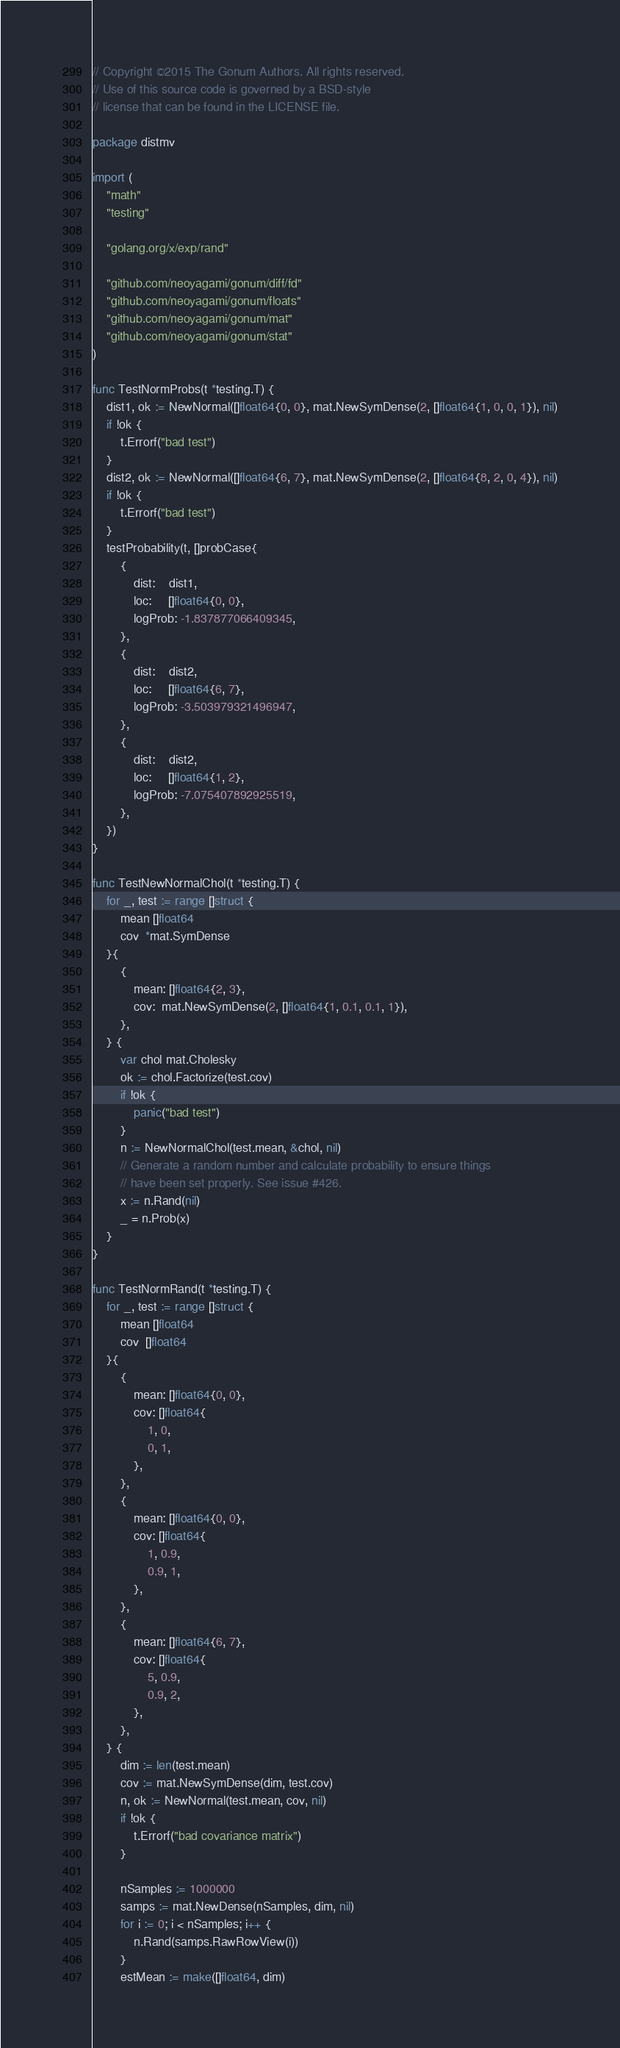<code> <loc_0><loc_0><loc_500><loc_500><_Go_>// Copyright ©2015 The Gonum Authors. All rights reserved.
// Use of this source code is governed by a BSD-style
// license that can be found in the LICENSE file.

package distmv

import (
	"math"
	"testing"

	"golang.org/x/exp/rand"

	"github.com/neoyagami/gonum/diff/fd"
	"github.com/neoyagami/gonum/floats"
	"github.com/neoyagami/gonum/mat"
	"github.com/neoyagami/gonum/stat"
)

func TestNormProbs(t *testing.T) {
	dist1, ok := NewNormal([]float64{0, 0}, mat.NewSymDense(2, []float64{1, 0, 0, 1}), nil)
	if !ok {
		t.Errorf("bad test")
	}
	dist2, ok := NewNormal([]float64{6, 7}, mat.NewSymDense(2, []float64{8, 2, 0, 4}), nil)
	if !ok {
		t.Errorf("bad test")
	}
	testProbability(t, []probCase{
		{
			dist:    dist1,
			loc:     []float64{0, 0},
			logProb: -1.837877066409345,
		},
		{
			dist:    dist2,
			loc:     []float64{6, 7},
			logProb: -3.503979321496947,
		},
		{
			dist:    dist2,
			loc:     []float64{1, 2},
			logProb: -7.075407892925519,
		},
	})
}

func TestNewNormalChol(t *testing.T) {
	for _, test := range []struct {
		mean []float64
		cov  *mat.SymDense
	}{
		{
			mean: []float64{2, 3},
			cov:  mat.NewSymDense(2, []float64{1, 0.1, 0.1, 1}),
		},
	} {
		var chol mat.Cholesky
		ok := chol.Factorize(test.cov)
		if !ok {
			panic("bad test")
		}
		n := NewNormalChol(test.mean, &chol, nil)
		// Generate a random number and calculate probability to ensure things
		// have been set properly. See issue #426.
		x := n.Rand(nil)
		_ = n.Prob(x)
	}
}

func TestNormRand(t *testing.T) {
	for _, test := range []struct {
		mean []float64
		cov  []float64
	}{
		{
			mean: []float64{0, 0},
			cov: []float64{
				1, 0,
				0, 1,
			},
		},
		{
			mean: []float64{0, 0},
			cov: []float64{
				1, 0.9,
				0.9, 1,
			},
		},
		{
			mean: []float64{6, 7},
			cov: []float64{
				5, 0.9,
				0.9, 2,
			},
		},
	} {
		dim := len(test.mean)
		cov := mat.NewSymDense(dim, test.cov)
		n, ok := NewNormal(test.mean, cov, nil)
		if !ok {
			t.Errorf("bad covariance matrix")
		}

		nSamples := 1000000
		samps := mat.NewDense(nSamples, dim, nil)
		for i := 0; i < nSamples; i++ {
			n.Rand(samps.RawRowView(i))
		}
		estMean := make([]float64, dim)</code> 